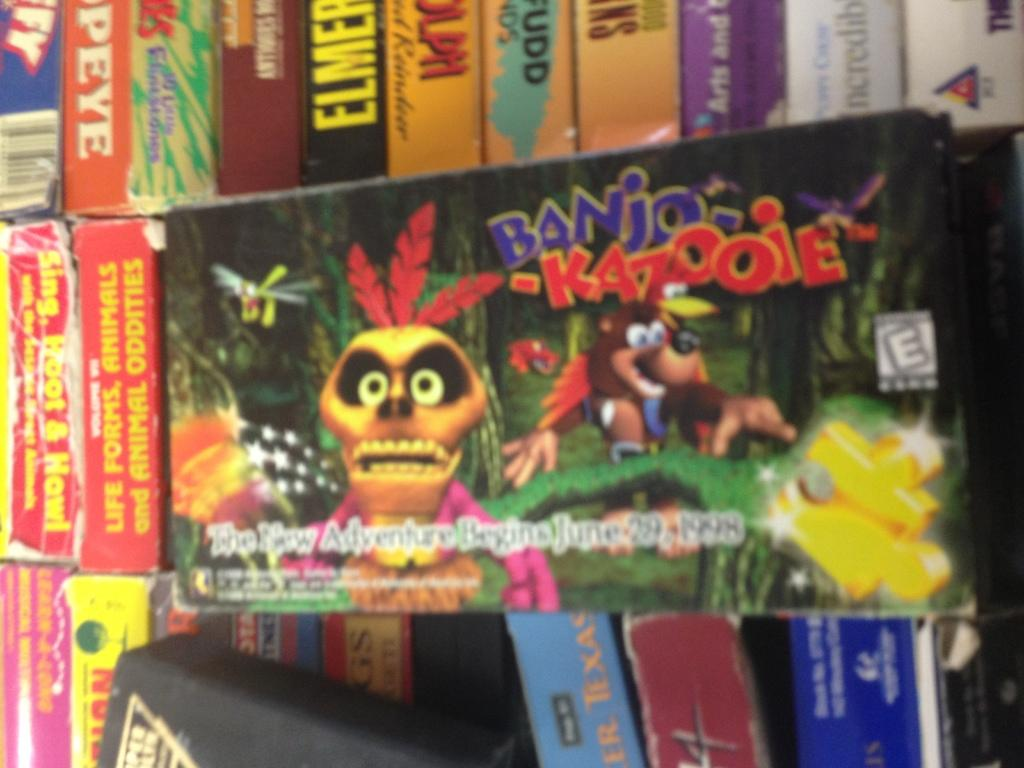<image>
Render a clear and concise summary of the photo. Banjo Kazooie game sits on a shelf with other games and books. 